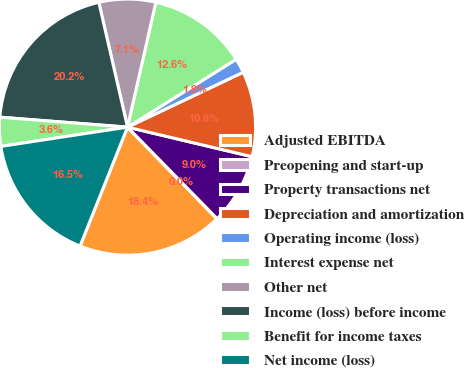<chart> <loc_0><loc_0><loc_500><loc_500><pie_chart><fcel>Adjusted EBITDA<fcel>Preopening and start-up<fcel>Property transactions net<fcel>Depreciation and amortization<fcel>Operating income (loss)<fcel>Interest expense net<fcel>Other net<fcel>Income (loss) before income<fcel>Benefit for income taxes<fcel>Net income (loss)<nl><fcel>18.36%<fcel>0.02%<fcel>8.96%<fcel>10.76%<fcel>1.83%<fcel>12.57%<fcel>7.15%<fcel>20.17%<fcel>3.64%<fcel>16.55%<nl></chart> 